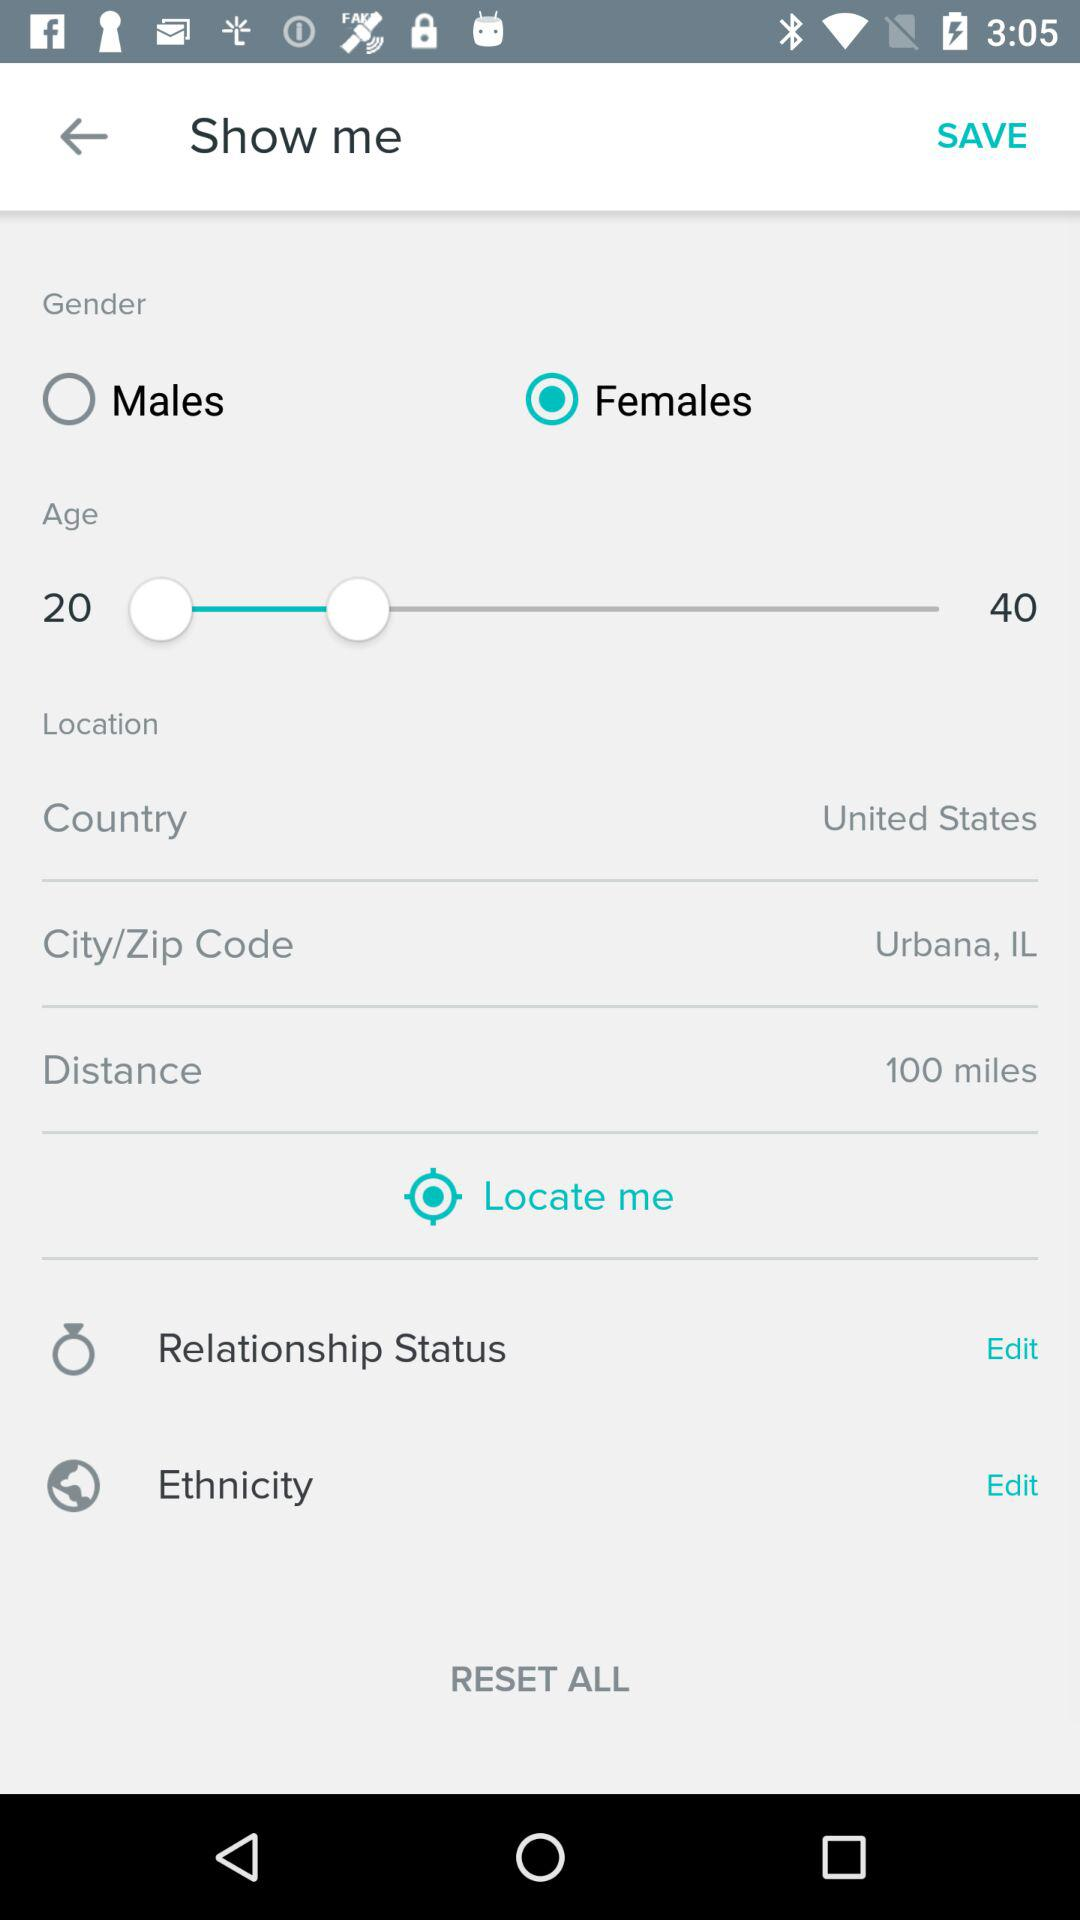What's the city name? The city name is Urbana. 